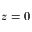Convert formula to latex. <formula><loc_0><loc_0><loc_500><loc_500>z = 0</formula> 